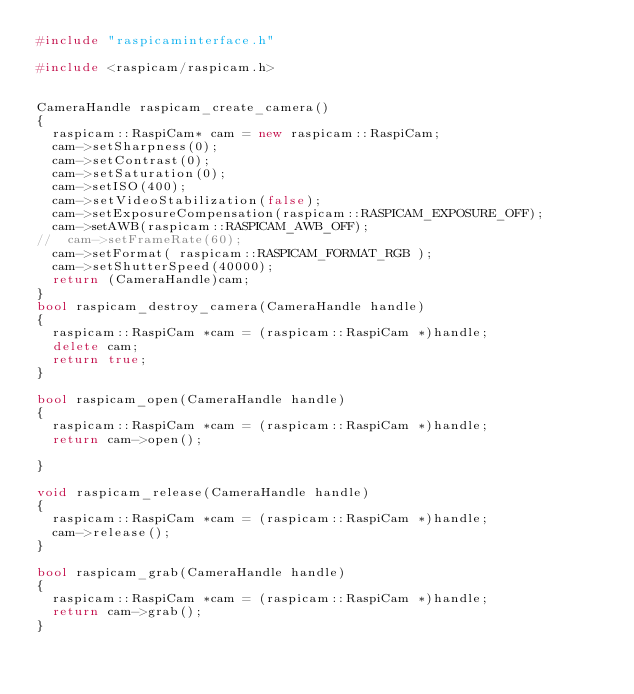<code> <loc_0><loc_0><loc_500><loc_500><_C++_>#include "raspicaminterface.h"

#include <raspicam/raspicam.h>


CameraHandle raspicam_create_camera()
{
  raspicam::RaspiCam* cam = new raspicam::RaspiCam;
  cam->setSharpness(0);
  cam->setContrast(0);
  cam->setSaturation(0);
  cam->setISO(400);
  cam->setVideoStabilization(false);
  cam->setExposureCompensation(raspicam::RASPICAM_EXPOSURE_OFF);
  cam->setAWB(raspicam::RASPICAM_AWB_OFF);
//  cam->setFrameRate(60);
  cam->setFormat( raspicam::RASPICAM_FORMAT_RGB );
  cam->setShutterSpeed(40000);
  return (CameraHandle)cam;
}
bool raspicam_destroy_camera(CameraHandle handle)
{
  raspicam::RaspiCam *cam = (raspicam::RaspiCam *)handle;
  delete cam;
  return true;
}

bool raspicam_open(CameraHandle handle)
{
  raspicam::RaspiCam *cam = (raspicam::RaspiCam *)handle;
  return cam->open();

}

void raspicam_release(CameraHandle handle)
{
  raspicam::RaspiCam *cam = (raspicam::RaspiCam *)handle;
  cam->release();
}

bool raspicam_grab(CameraHandle handle)
{
  raspicam::RaspiCam *cam = (raspicam::RaspiCam *)handle;
  return cam->grab();
}
</code> 